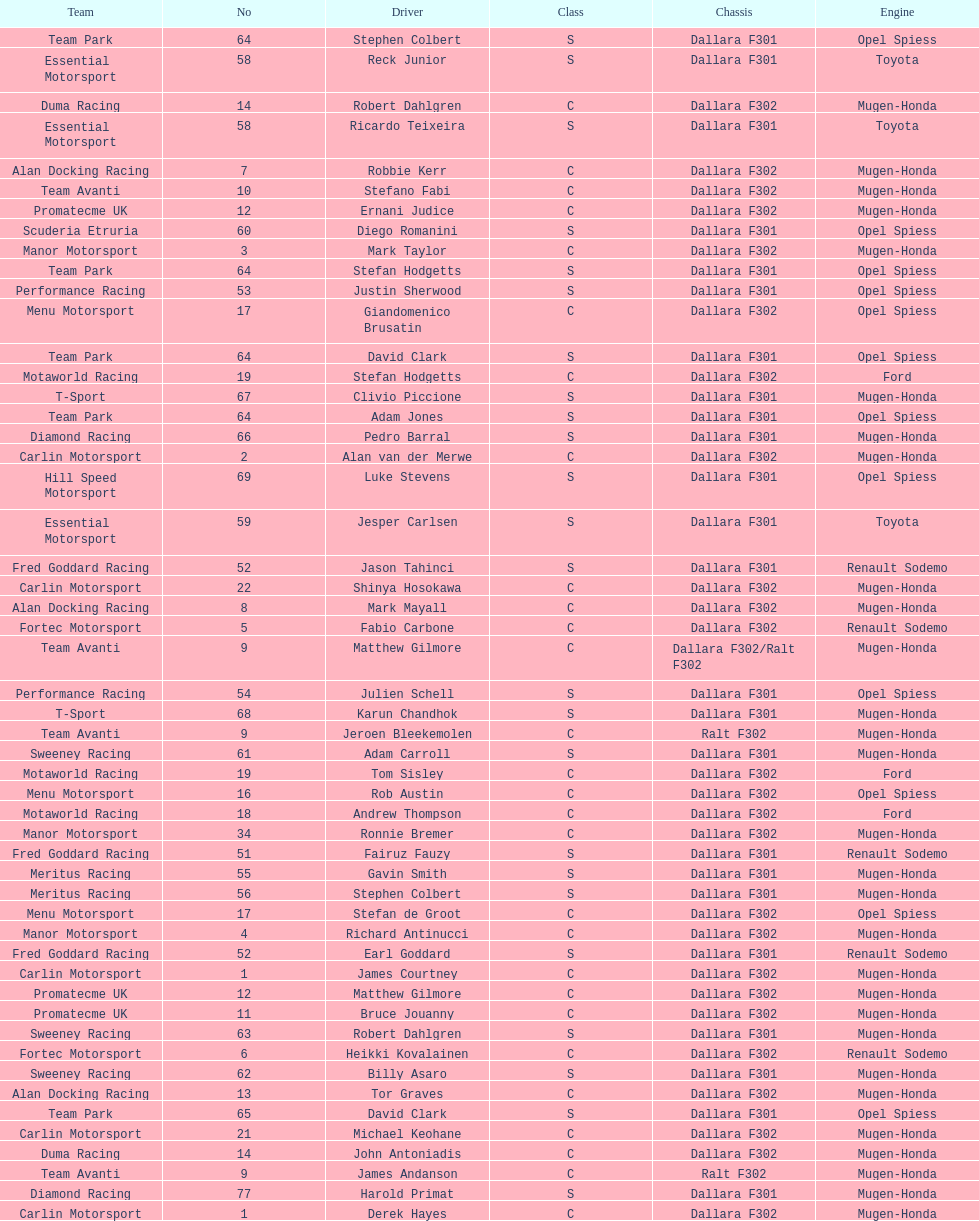Who had more drivers, team avanti or motaworld racing? Team Avanti. 